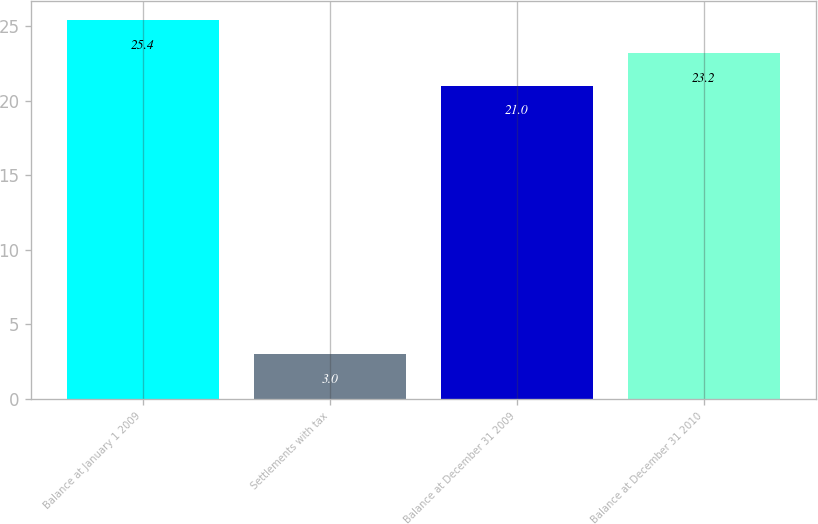Convert chart. <chart><loc_0><loc_0><loc_500><loc_500><bar_chart><fcel>Balance at January 1 2009<fcel>Settlements with tax<fcel>Balance at December 31 2009<fcel>Balance at December 31 2010<nl><fcel>25.4<fcel>3<fcel>21<fcel>23.2<nl></chart> 